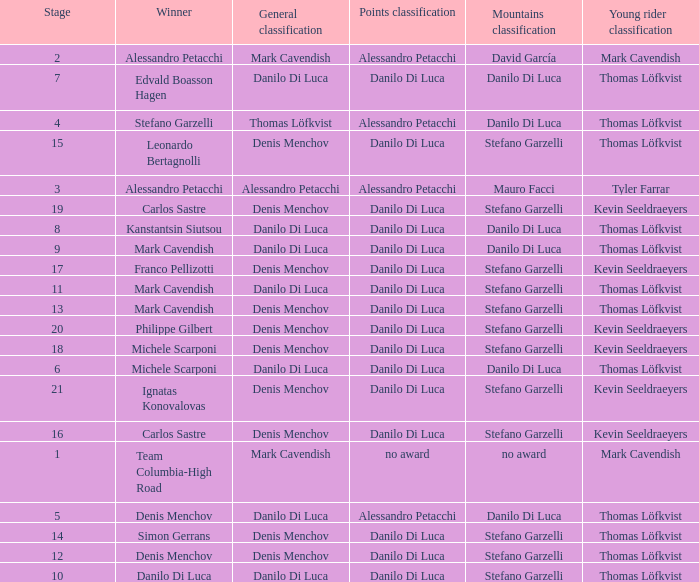When 19 is the stage who is the points classification? Danilo Di Luca. 